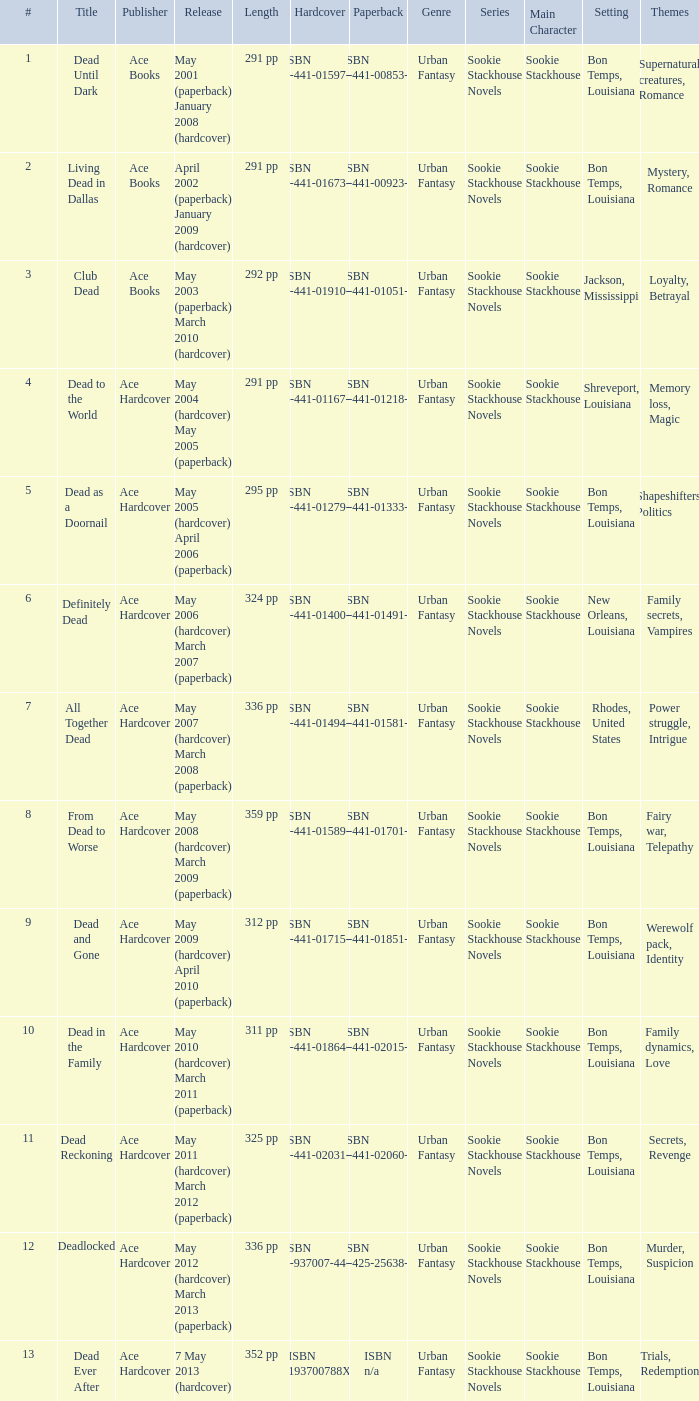What is the ISBN of "Dead as a Doornail? ISBN 0-441-01333-3. 